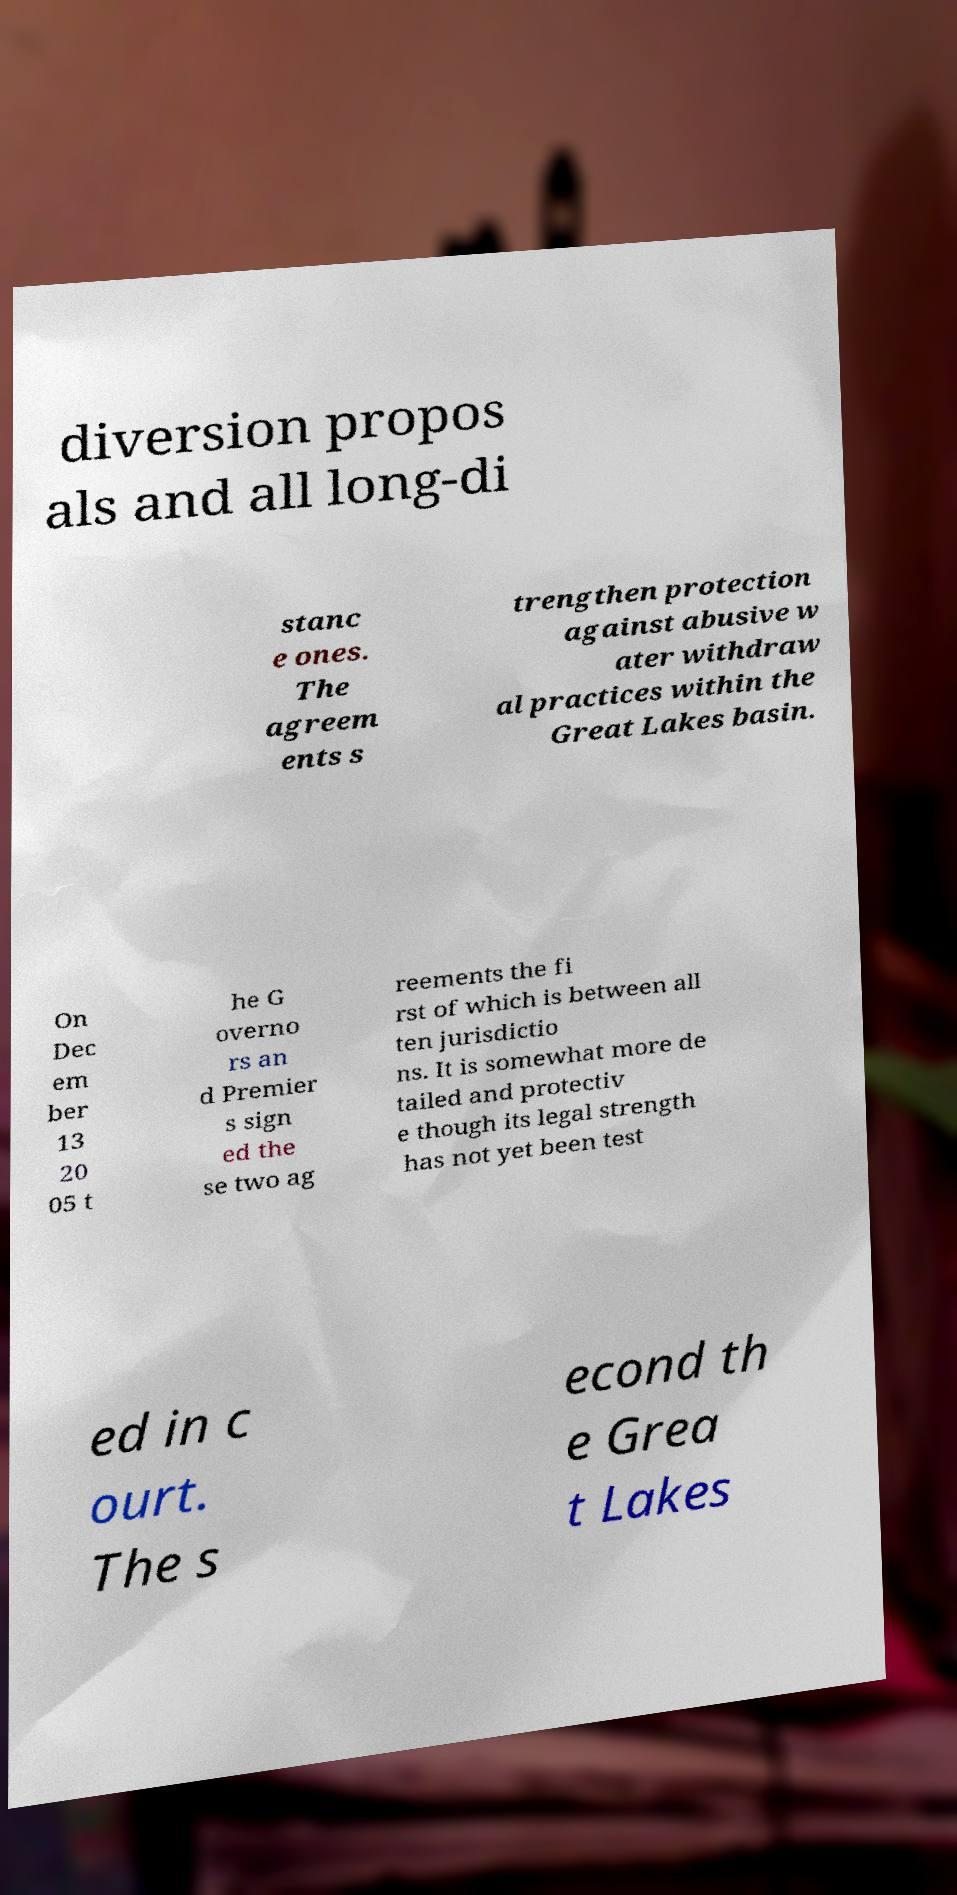There's text embedded in this image that I need extracted. Can you transcribe it verbatim? diversion propos als and all long-di stanc e ones. The agreem ents s trengthen protection against abusive w ater withdraw al practices within the Great Lakes basin. On Dec em ber 13 20 05 t he G overno rs an d Premier s sign ed the se two ag reements the fi rst of which is between all ten jurisdictio ns. It is somewhat more de tailed and protectiv e though its legal strength has not yet been test ed in c ourt. The s econd th e Grea t Lakes 